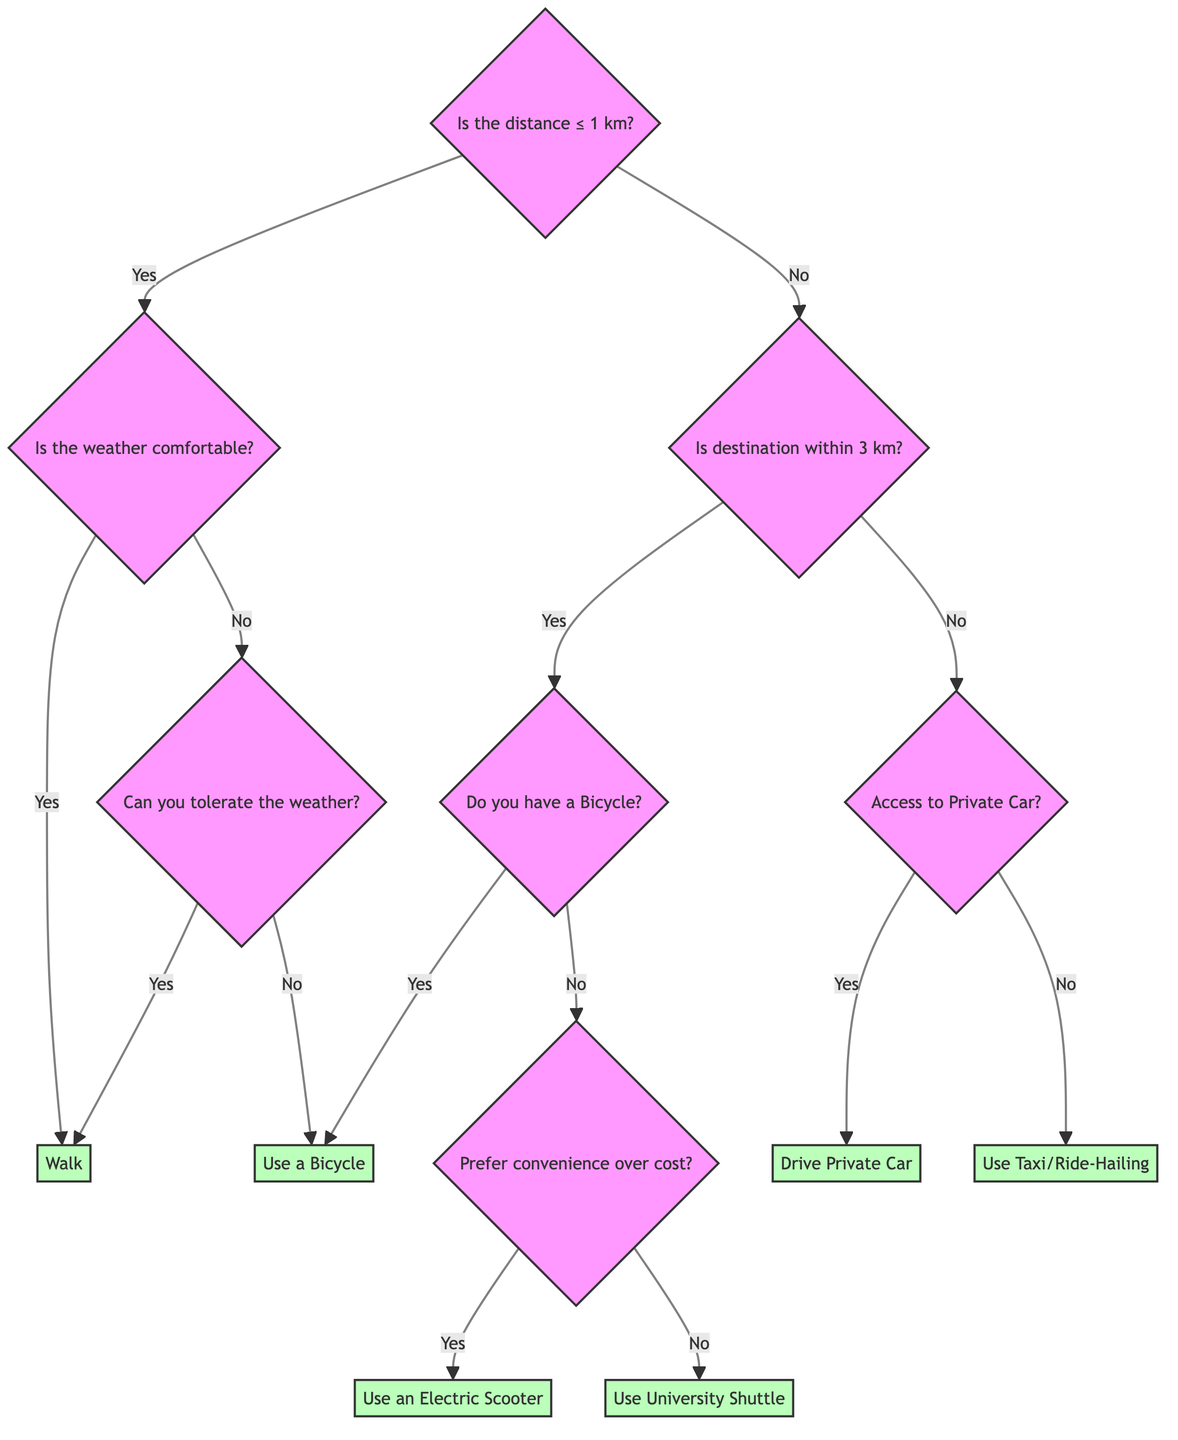Is the first question about distance to the destination? The first question in the decision tree is indeed about the distance to the destination, specifically asking if it is less than or equal to 1 km.
Answer: Yes How many decisions are there in the diagram? In the decision tree, there are a total of four decisions: Walk, Use a Bicycle, Use an Electric Scooter, Use University Shuttle, Drive Private Car, and Use Taxi or Ride-Hailing Service.
Answer: Six What decision comes after the question "Is the weather comfortable for walking?" if the answer is "No"? If the answer to the question about the weather being comfortable is "No", the next question is "Can you walk and tolerate the weather?".
Answer: Can you walk and tolerate the weather? What is the time cost for using a bicycle if the distance is less than or equal to 1 km? When the distance is less than or equal to 1 km, using a bicycle takes approximately 5-10 minutes.
Answer: 5-10 minutes What happens if you answer "No" to having a bicycle when the destination is within 3 km? If the answer is "No" to having a bicycle when the destination is within 3 km, the next question is "Would you prefer convenience over cost?".
Answer: Would you prefer convenience over cost? Explain the pathway to choosing the University Shuttle. To reach the decision to use the University Shuttle, the user must first answer "No" to the question about having a bicycle when the destination is within 3 km and then answer "No" to preferring convenience over cost. This leads to the decision of using the University Shuttle.
Answer: Use University Shuttle What is the monetary cost associated with driving a private car? The monetary cost associated with driving a private car is between 10-20 SAR.
Answer: 10-20 SAR What is the health benefit of walking if the weather is comfortable? If the weather is comfortable for walking, the health benefit of walking is categorized as "High".
Answer: High What question follows if the distance is greater than 3 km and you don't have access to a private car? The question that follows, in this case, is whether you would use a Taxi or Ride-Hailing Service, as there is no other mode of transport available.
Answer: Use Taxi or Ride-Hailing Service 